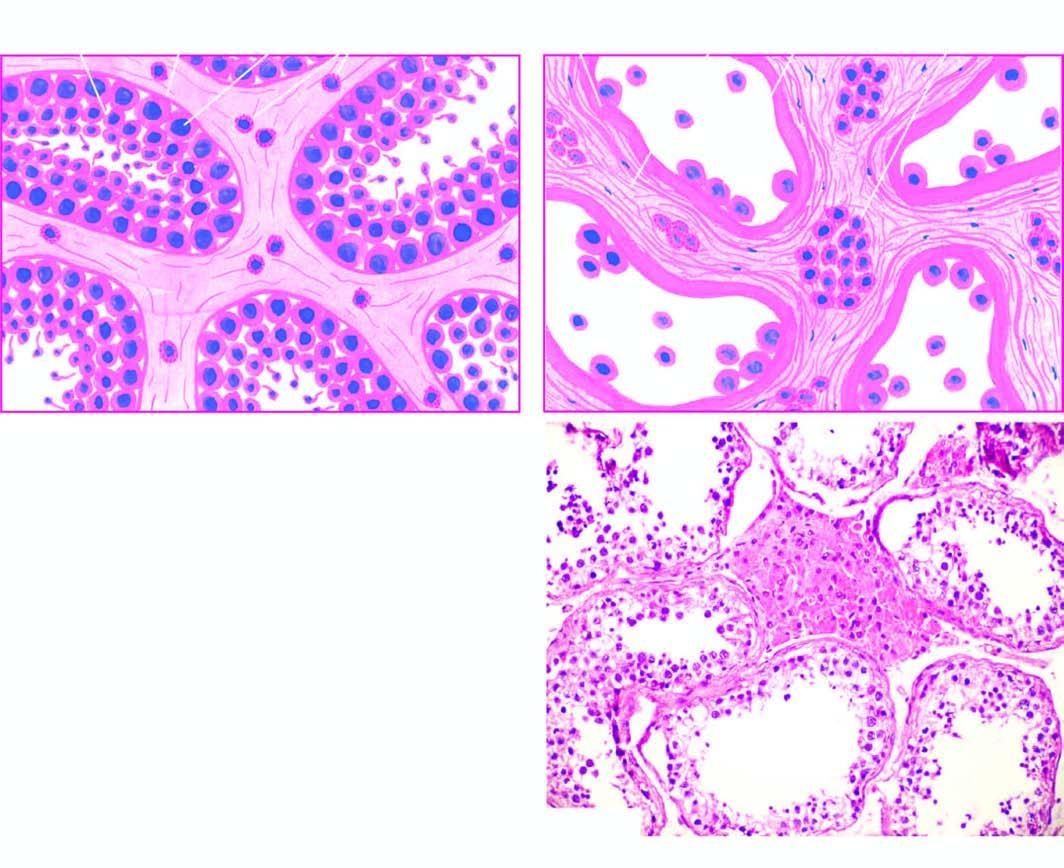what is contrasted with that of cryptorchid testis?
Answer the question using a single word or phrase. Microscopic appearance of normal testis 